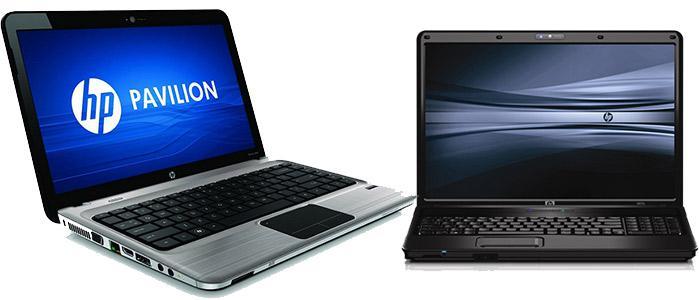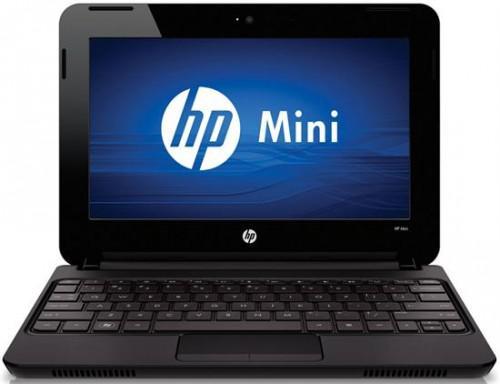The first image is the image on the left, the second image is the image on the right. Evaluate the accuracy of this statement regarding the images: "The laptop in the right image is displayed turned at an angle.". Is it true? Answer yes or no. No. 